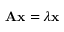<formula> <loc_0><loc_0><loc_500><loc_500>A x = \lambda x</formula> 